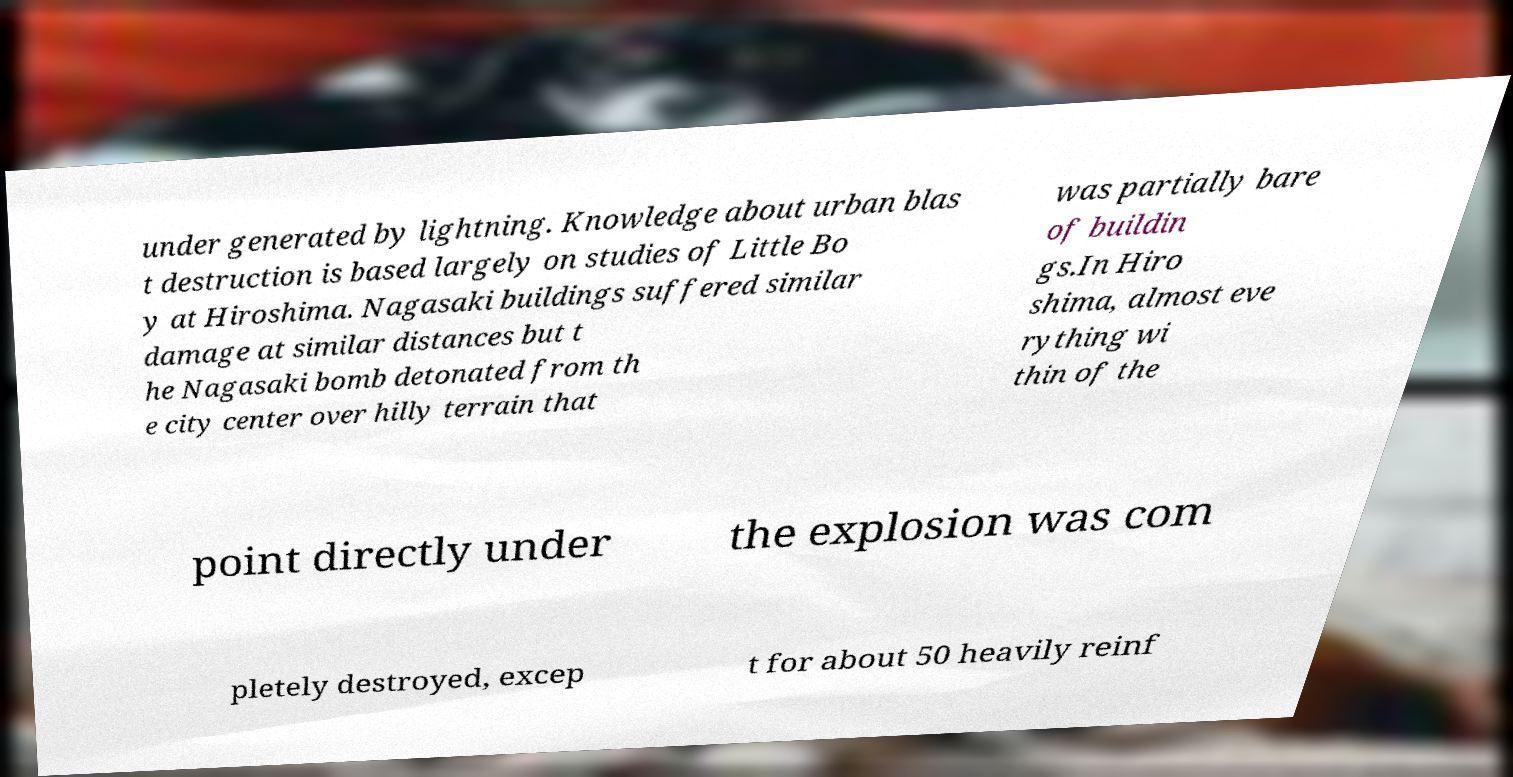Please read and relay the text visible in this image. What does it say? under generated by lightning. Knowledge about urban blas t destruction is based largely on studies of Little Bo y at Hiroshima. Nagasaki buildings suffered similar damage at similar distances but t he Nagasaki bomb detonated from th e city center over hilly terrain that was partially bare of buildin gs.In Hiro shima, almost eve rything wi thin of the point directly under the explosion was com pletely destroyed, excep t for about 50 heavily reinf 